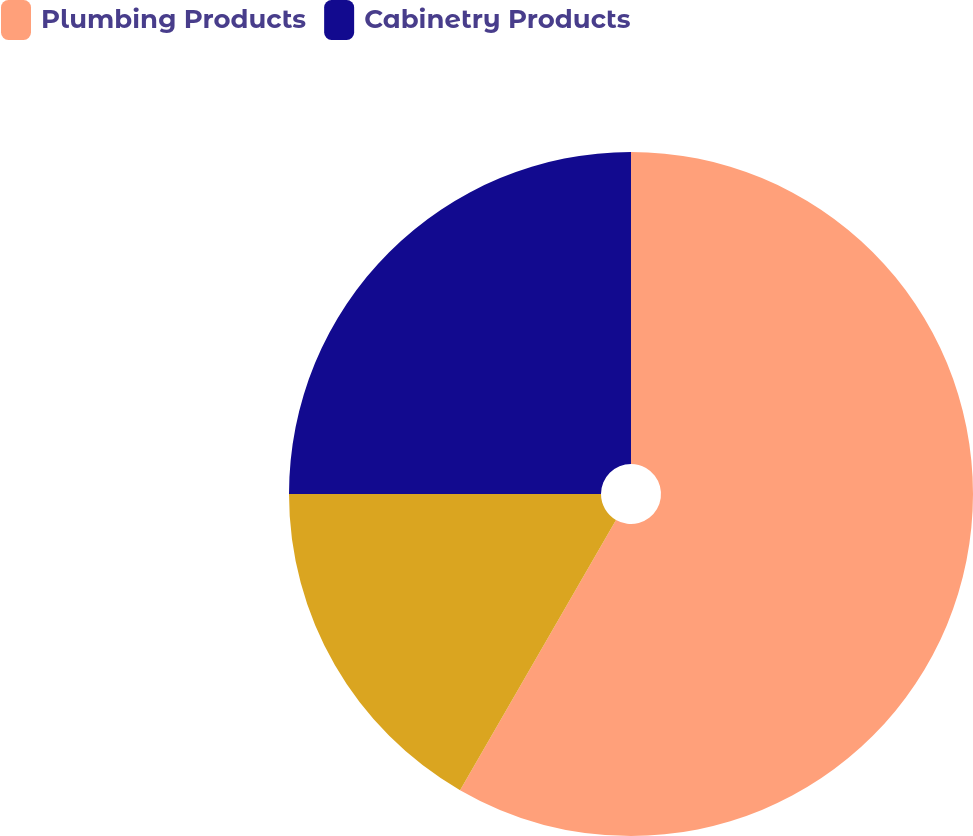Convert chart. <chart><loc_0><loc_0><loc_500><loc_500><pie_chart><fcel>Plumbing Products<fcel>Unnamed: 1<fcel>Cabinetry Products<nl><fcel>58.33%<fcel>16.67%<fcel>25.0%<nl></chart> 